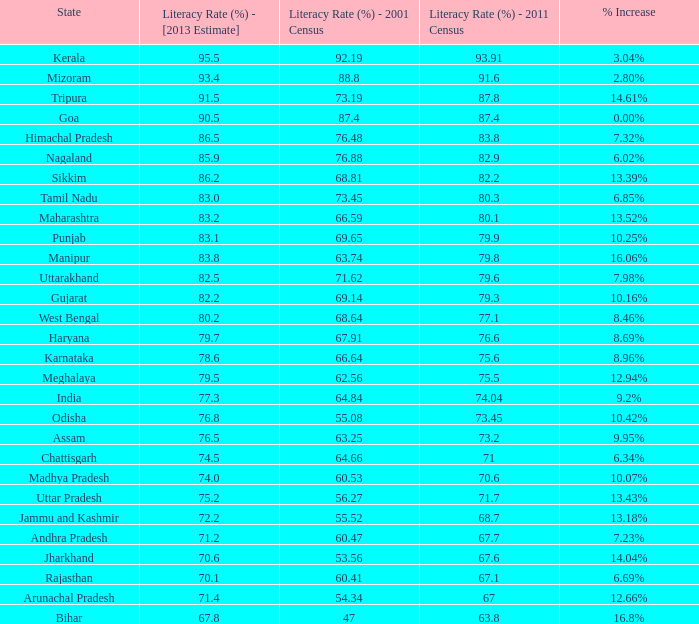What is the average increase in literacy for the states that had a rate higher than 73.2% in 2011, less than 68.81% in 2001, and an estimate of 76.8% for 2013? 10.42%. Give me the full table as a dictionary. {'header': ['State', 'Literacy Rate (%) - [2013 Estimate]', 'Literacy Rate (%) - 2001 Census', 'Literacy Rate (%) - 2011 Census', '% Increase'], 'rows': [['Kerala', '95.5', '92.19', '93.91', '3.04%'], ['Mizoram', '93.4', '88.8', '91.6', '2.80%'], ['Tripura', '91.5', '73.19', '87.8', '14.61%'], ['Goa', '90.5', '87.4', '87.4', '0.00%'], ['Himachal Pradesh', '86.5', '76.48', '83.8', '7.32%'], ['Nagaland', '85.9', '76.88', '82.9', '6.02%'], ['Sikkim', '86.2', '68.81', '82.2', '13.39%'], ['Tamil Nadu', '83.0', '73.45', '80.3', '6.85%'], ['Maharashtra', '83.2', '66.59', '80.1', '13.52%'], ['Punjab', '83.1', '69.65', '79.9', '10.25%'], ['Manipur', '83.8', '63.74', '79.8', '16.06%'], ['Uttarakhand', '82.5', '71.62', '79.6', '7.98%'], ['Gujarat', '82.2', '69.14', '79.3', '10.16%'], ['West Bengal', '80.2', '68.64', '77.1', '8.46%'], ['Haryana', '79.7', '67.91', '76.6', '8.69%'], ['Karnataka', '78.6', '66.64', '75.6', '8.96%'], ['Meghalaya', '79.5', '62.56', '75.5', '12.94%'], ['India', '77.3', '64.84', '74.04', '9.2%'], ['Odisha', '76.8', '55.08', '73.45', '10.42%'], ['Assam', '76.5', '63.25', '73.2', '9.95%'], ['Chattisgarh', '74.5', '64.66', '71', '6.34%'], ['Madhya Pradesh', '74.0', '60.53', '70.6', '10.07%'], ['Uttar Pradesh', '75.2', '56.27', '71.7', '13.43%'], ['Jammu and Kashmir', '72.2', '55.52', '68.7', '13.18%'], ['Andhra Pradesh', '71.2', '60.47', '67.7', '7.23%'], ['Jharkhand', '70.6', '53.56', '67.6', '14.04%'], ['Rajasthan', '70.1', '60.41', '67.1', '6.69%'], ['Arunachal Pradesh', '71.4', '54.34', '67', '12.66%'], ['Bihar', '67.8', '47', '63.8', '16.8%']]} 